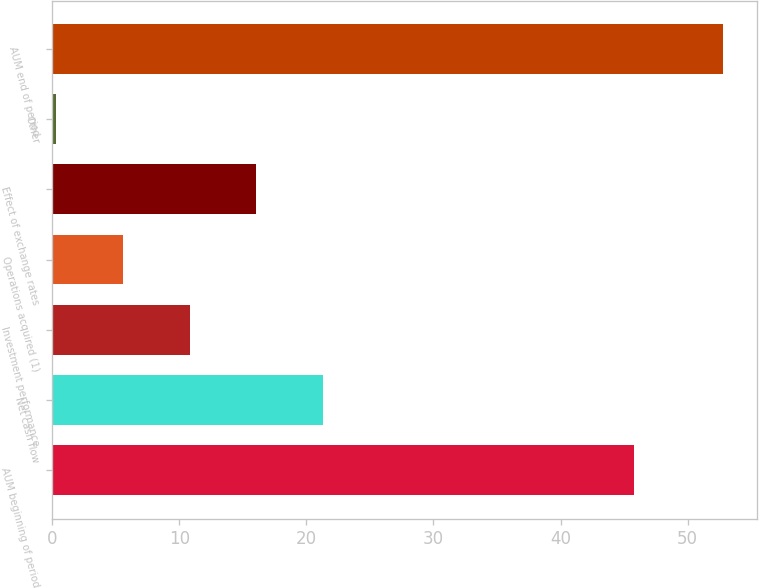Convert chart. <chart><loc_0><loc_0><loc_500><loc_500><bar_chart><fcel>AUM beginning of period<fcel>Net cash flow<fcel>Investment performance<fcel>Operations acquired (1)<fcel>Effect of exchange rates<fcel>Other<fcel>AUM end of period<nl><fcel>45.8<fcel>21.3<fcel>10.8<fcel>5.55<fcel>16.05<fcel>0.3<fcel>52.8<nl></chart> 